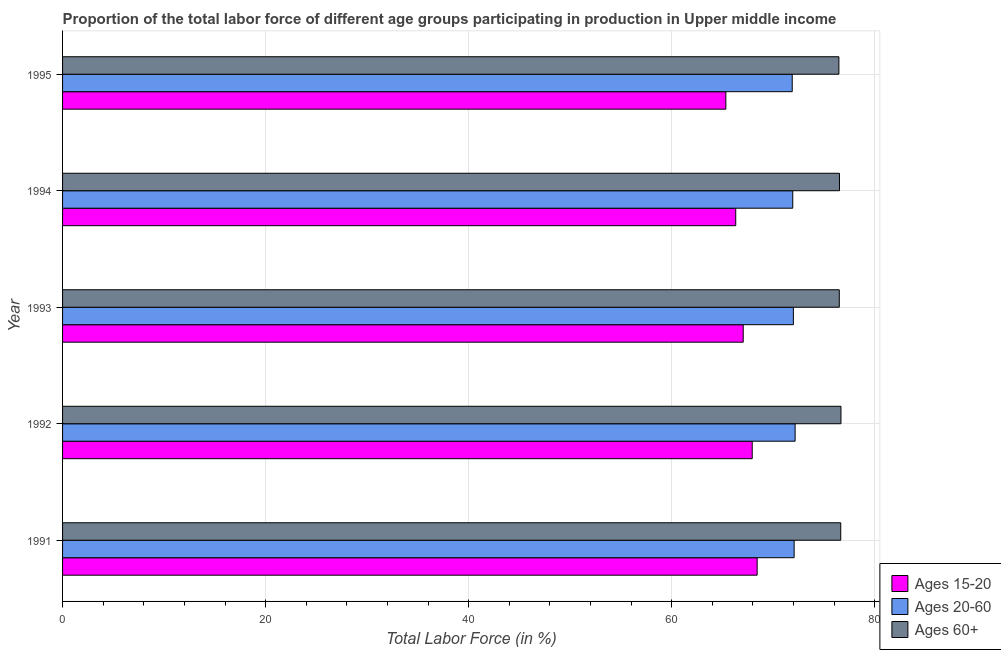How many different coloured bars are there?
Keep it short and to the point. 3. How many groups of bars are there?
Your answer should be compact. 5. Are the number of bars per tick equal to the number of legend labels?
Offer a very short reply. Yes. What is the percentage of labor force above age 60 in 1992?
Your response must be concise. 76.67. Across all years, what is the maximum percentage of labor force within the age group 20-60?
Make the answer very short. 72.16. Across all years, what is the minimum percentage of labor force above age 60?
Make the answer very short. 76.47. In which year was the percentage of labor force within the age group 15-20 maximum?
Give a very brief answer. 1991. What is the total percentage of labor force within the age group 20-60 in the graph?
Your response must be concise. 360. What is the difference between the percentage of labor force above age 60 in 1991 and that in 1994?
Your answer should be compact. 0.12. What is the difference between the percentage of labor force above age 60 in 1992 and the percentage of labor force within the age group 15-20 in 1995?
Offer a terse response. 11.34. In the year 1991, what is the difference between the percentage of labor force within the age group 20-60 and percentage of labor force above age 60?
Your answer should be very brief. -4.59. In how many years, is the percentage of labor force within the age group 20-60 greater than 28 %?
Ensure brevity in your answer.  5. What is the difference between the highest and the second highest percentage of labor force above age 60?
Offer a terse response. 0.02. What is the difference between the highest and the lowest percentage of labor force within the age group 20-60?
Your answer should be compact. 0.29. Is the sum of the percentage of labor force within the age group 20-60 in 1993 and 1995 greater than the maximum percentage of labor force within the age group 15-20 across all years?
Your answer should be very brief. Yes. What does the 2nd bar from the top in 1993 represents?
Your answer should be very brief. Ages 20-60. What does the 3rd bar from the bottom in 1992 represents?
Offer a very short reply. Ages 60+. Are all the bars in the graph horizontal?
Give a very brief answer. Yes. Are the values on the major ticks of X-axis written in scientific E-notation?
Keep it short and to the point. No. Where does the legend appear in the graph?
Provide a succinct answer. Bottom right. How are the legend labels stacked?
Provide a succinct answer. Vertical. What is the title of the graph?
Give a very brief answer. Proportion of the total labor force of different age groups participating in production in Upper middle income. What is the Total Labor Force (in %) of Ages 15-20 in 1991?
Your answer should be very brief. 68.42. What is the Total Labor Force (in %) in Ages 20-60 in 1991?
Your answer should be compact. 72.06. What is the Total Labor Force (in %) of Ages 60+ in 1991?
Keep it short and to the point. 76.65. What is the Total Labor Force (in %) of Ages 15-20 in 1992?
Provide a short and direct response. 67.93. What is the Total Labor Force (in %) of Ages 20-60 in 1992?
Offer a terse response. 72.16. What is the Total Labor Force (in %) of Ages 60+ in 1992?
Ensure brevity in your answer.  76.67. What is the Total Labor Force (in %) in Ages 15-20 in 1993?
Give a very brief answer. 67.04. What is the Total Labor Force (in %) in Ages 20-60 in 1993?
Your answer should be very brief. 71.98. What is the Total Labor Force (in %) of Ages 60+ in 1993?
Your answer should be very brief. 76.51. What is the Total Labor Force (in %) of Ages 15-20 in 1994?
Your answer should be very brief. 66.31. What is the Total Labor Force (in %) in Ages 20-60 in 1994?
Provide a short and direct response. 71.92. What is the Total Labor Force (in %) in Ages 60+ in 1994?
Provide a succinct answer. 76.53. What is the Total Labor Force (in %) of Ages 15-20 in 1995?
Provide a succinct answer. 65.33. What is the Total Labor Force (in %) in Ages 20-60 in 1995?
Provide a short and direct response. 71.87. What is the Total Labor Force (in %) in Ages 60+ in 1995?
Offer a terse response. 76.47. Across all years, what is the maximum Total Labor Force (in %) of Ages 15-20?
Give a very brief answer. 68.42. Across all years, what is the maximum Total Labor Force (in %) of Ages 20-60?
Ensure brevity in your answer.  72.16. Across all years, what is the maximum Total Labor Force (in %) of Ages 60+?
Provide a short and direct response. 76.67. Across all years, what is the minimum Total Labor Force (in %) in Ages 15-20?
Your answer should be compact. 65.33. Across all years, what is the minimum Total Labor Force (in %) in Ages 20-60?
Offer a terse response. 71.87. Across all years, what is the minimum Total Labor Force (in %) of Ages 60+?
Provide a succinct answer. 76.47. What is the total Total Labor Force (in %) of Ages 15-20 in the graph?
Give a very brief answer. 335.03. What is the total Total Labor Force (in %) of Ages 20-60 in the graph?
Offer a terse response. 360. What is the total Total Labor Force (in %) of Ages 60+ in the graph?
Ensure brevity in your answer.  382.83. What is the difference between the Total Labor Force (in %) of Ages 15-20 in 1991 and that in 1992?
Make the answer very short. 0.49. What is the difference between the Total Labor Force (in %) of Ages 20-60 in 1991 and that in 1992?
Your response must be concise. -0.1. What is the difference between the Total Labor Force (in %) in Ages 60+ in 1991 and that in 1992?
Provide a short and direct response. -0.02. What is the difference between the Total Labor Force (in %) of Ages 15-20 in 1991 and that in 1993?
Your answer should be compact. 1.37. What is the difference between the Total Labor Force (in %) in Ages 20-60 in 1991 and that in 1993?
Your response must be concise. 0.08. What is the difference between the Total Labor Force (in %) of Ages 60+ in 1991 and that in 1993?
Provide a succinct answer. 0.14. What is the difference between the Total Labor Force (in %) in Ages 15-20 in 1991 and that in 1994?
Make the answer very short. 2.11. What is the difference between the Total Labor Force (in %) in Ages 20-60 in 1991 and that in 1994?
Make the answer very short. 0.14. What is the difference between the Total Labor Force (in %) in Ages 60+ in 1991 and that in 1994?
Your answer should be compact. 0.12. What is the difference between the Total Labor Force (in %) in Ages 15-20 in 1991 and that in 1995?
Provide a succinct answer. 3.09. What is the difference between the Total Labor Force (in %) in Ages 20-60 in 1991 and that in 1995?
Offer a very short reply. 0.19. What is the difference between the Total Labor Force (in %) of Ages 60+ in 1991 and that in 1995?
Make the answer very short. 0.18. What is the difference between the Total Labor Force (in %) of Ages 15-20 in 1992 and that in 1993?
Offer a very short reply. 0.89. What is the difference between the Total Labor Force (in %) of Ages 20-60 in 1992 and that in 1993?
Make the answer very short. 0.17. What is the difference between the Total Labor Force (in %) in Ages 60+ in 1992 and that in 1993?
Your answer should be compact. 0.16. What is the difference between the Total Labor Force (in %) in Ages 15-20 in 1992 and that in 1994?
Provide a succinct answer. 1.62. What is the difference between the Total Labor Force (in %) of Ages 20-60 in 1992 and that in 1994?
Ensure brevity in your answer.  0.23. What is the difference between the Total Labor Force (in %) of Ages 60+ in 1992 and that in 1994?
Make the answer very short. 0.15. What is the difference between the Total Labor Force (in %) of Ages 15-20 in 1992 and that in 1995?
Give a very brief answer. 2.6. What is the difference between the Total Labor Force (in %) of Ages 20-60 in 1992 and that in 1995?
Make the answer very short. 0.29. What is the difference between the Total Labor Force (in %) in Ages 60+ in 1992 and that in 1995?
Make the answer very short. 0.2. What is the difference between the Total Labor Force (in %) in Ages 15-20 in 1993 and that in 1994?
Your response must be concise. 0.74. What is the difference between the Total Labor Force (in %) in Ages 20-60 in 1993 and that in 1994?
Make the answer very short. 0.06. What is the difference between the Total Labor Force (in %) of Ages 60+ in 1993 and that in 1994?
Ensure brevity in your answer.  -0.02. What is the difference between the Total Labor Force (in %) of Ages 15-20 in 1993 and that in 1995?
Your response must be concise. 1.71. What is the difference between the Total Labor Force (in %) in Ages 20-60 in 1993 and that in 1995?
Your answer should be very brief. 0.11. What is the difference between the Total Labor Force (in %) of Ages 60+ in 1993 and that in 1995?
Keep it short and to the point. 0.04. What is the difference between the Total Labor Force (in %) in Ages 15-20 in 1994 and that in 1995?
Make the answer very short. 0.98. What is the difference between the Total Labor Force (in %) in Ages 20-60 in 1994 and that in 1995?
Your answer should be compact. 0.05. What is the difference between the Total Labor Force (in %) in Ages 60+ in 1994 and that in 1995?
Make the answer very short. 0.06. What is the difference between the Total Labor Force (in %) in Ages 15-20 in 1991 and the Total Labor Force (in %) in Ages 20-60 in 1992?
Keep it short and to the point. -3.74. What is the difference between the Total Labor Force (in %) of Ages 15-20 in 1991 and the Total Labor Force (in %) of Ages 60+ in 1992?
Your response must be concise. -8.25. What is the difference between the Total Labor Force (in %) of Ages 20-60 in 1991 and the Total Labor Force (in %) of Ages 60+ in 1992?
Give a very brief answer. -4.61. What is the difference between the Total Labor Force (in %) in Ages 15-20 in 1991 and the Total Labor Force (in %) in Ages 20-60 in 1993?
Provide a succinct answer. -3.57. What is the difference between the Total Labor Force (in %) in Ages 15-20 in 1991 and the Total Labor Force (in %) in Ages 60+ in 1993?
Your response must be concise. -8.09. What is the difference between the Total Labor Force (in %) in Ages 20-60 in 1991 and the Total Labor Force (in %) in Ages 60+ in 1993?
Provide a short and direct response. -4.45. What is the difference between the Total Labor Force (in %) of Ages 15-20 in 1991 and the Total Labor Force (in %) of Ages 20-60 in 1994?
Your response must be concise. -3.51. What is the difference between the Total Labor Force (in %) in Ages 15-20 in 1991 and the Total Labor Force (in %) in Ages 60+ in 1994?
Give a very brief answer. -8.11. What is the difference between the Total Labor Force (in %) in Ages 20-60 in 1991 and the Total Labor Force (in %) in Ages 60+ in 1994?
Offer a terse response. -4.47. What is the difference between the Total Labor Force (in %) of Ages 15-20 in 1991 and the Total Labor Force (in %) of Ages 20-60 in 1995?
Keep it short and to the point. -3.45. What is the difference between the Total Labor Force (in %) of Ages 15-20 in 1991 and the Total Labor Force (in %) of Ages 60+ in 1995?
Make the answer very short. -8.05. What is the difference between the Total Labor Force (in %) in Ages 20-60 in 1991 and the Total Labor Force (in %) in Ages 60+ in 1995?
Give a very brief answer. -4.41. What is the difference between the Total Labor Force (in %) in Ages 15-20 in 1992 and the Total Labor Force (in %) in Ages 20-60 in 1993?
Your answer should be compact. -4.05. What is the difference between the Total Labor Force (in %) of Ages 15-20 in 1992 and the Total Labor Force (in %) of Ages 60+ in 1993?
Provide a succinct answer. -8.58. What is the difference between the Total Labor Force (in %) in Ages 20-60 in 1992 and the Total Labor Force (in %) in Ages 60+ in 1993?
Provide a short and direct response. -4.35. What is the difference between the Total Labor Force (in %) in Ages 15-20 in 1992 and the Total Labor Force (in %) in Ages 20-60 in 1994?
Provide a succinct answer. -3.99. What is the difference between the Total Labor Force (in %) in Ages 15-20 in 1992 and the Total Labor Force (in %) in Ages 60+ in 1994?
Provide a succinct answer. -8.6. What is the difference between the Total Labor Force (in %) in Ages 20-60 in 1992 and the Total Labor Force (in %) in Ages 60+ in 1994?
Your response must be concise. -4.37. What is the difference between the Total Labor Force (in %) of Ages 15-20 in 1992 and the Total Labor Force (in %) of Ages 20-60 in 1995?
Make the answer very short. -3.94. What is the difference between the Total Labor Force (in %) in Ages 15-20 in 1992 and the Total Labor Force (in %) in Ages 60+ in 1995?
Offer a terse response. -8.54. What is the difference between the Total Labor Force (in %) in Ages 20-60 in 1992 and the Total Labor Force (in %) in Ages 60+ in 1995?
Keep it short and to the point. -4.31. What is the difference between the Total Labor Force (in %) in Ages 15-20 in 1993 and the Total Labor Force (in %) in Ages 20-60 in 1994?
Provide a succinct answer. -4.88. What is the difference between the Total Labor Force (in %) in Ages 15-20 in 1993 and the Total Labor Force (in %) in Ages 60+ in 1994?
Your answer should be compact. -9.48. What is the difference between the Total Labor Force (in %) in Ages 20-60 in 1993 and the Total Labor Force (in %) in Ages 60+ in 1994?
Your answer should be very brief. -4.54. What is the difference between the Total Labor Force (in %) of Ages 15-20 in 1993 and the Total Labor Force (in %) of Ages 20-60 in 1995?
Provide a short and direct response. -4.83. What is the difference between the Total Labor Force (in %) of Ages 15-20 in 1993 and the Total Labor Force (in %) of Ages 60+ in 1995?
Ensure brevity in your answer.  -9.42. What is the difference between the Total Labor Force (in %) in Ages 20-60 in 1993 and the Total Labor Force (in %) in Ages 60+ in 1995?
Provide a short and direct response. -4.48. What is the difference between the Total Labor Force (in %) in Ages 15-20 in 1994 and the Total Labor Force (in %) in Ages 20-60 in 1995?
Ensure brevity in your answer.  -5.56. What is the difference between the Total Labor Force (in %) of Ages 15-20 in 1994 and the Total Labor Force (in %) of Ages 60+ in 1995?
Your answer should be very brief. -10.16. What is the difference between the Total Labor Force (in %) of Ages 20-60 in 1994 and the Total Labor Force (in %) of Ages 60+ in 1995?
Provide a succinct answer. -4.54. What is the average Total Labor Force (in %) of Ages 15-20 per year?
Offer a terse response. 67.01. What is the average Total Labor Force (in %) in Ages 20-60 per year?
Your answer should be compact. 72. What is the average Total Labor Force (in %) of Ages 60+ per year?
Provide a short and direct response. 76.57. In the year 1991, what is the difference between the Total Labor Force (in %) of Ages 15-20 and Total Labor Force (in %) of Ages 20-60?
Provide a succinct answer. -3.64. In the year 1991, what is the difference between the Total Labor Force (in %) of Ages 15-20 and Total Labor Force (in %) of Ages 60+?
Your answer should be compact. -8.23. In the year 1991, what is the difference between the Total Labor Force (in %) in Ages 20-60 and Total Labor Force (in %) in Ages 60+?
Give a very brief answer. -4.59. In the year 1992, what is the difference between the Total Labor Force (in %) of Ages 15-20 and Total Labor Force (in %) of Ages 20-60?
Ensure brevity in your answer.  -4.23. In the year 1992, what is the difference between the Total Labor Force (in %) of Ages 15-20 and Total Labor Force (in %) of Ages 60+?
Provide a short and direct response. -8.74. In the year 1992, what is the difference between the Total Labor Force (in %) of Ages 20-60 and Total Labor Force (in %) of Ages 60+?
Provide a short and direct response. -4.52. In the year 1993, what is the difference between the Total Labor Force (in %) in Ages 15-20 and Total Labor Force (in %) in Ages 20-60?
Provide a short and direct response. -4.94. In the year 1993, what is the difference between the Total Labor Force (in %) in Ages 15-20 and Total Labor Force (in %) in Ages 60+?
Offer a very short reply. -9.46. In the year 1993, what is the difference between the Total Labor Force (in %) of Ages 20-60 and Total Labor Force (in %) of Ages 60+?
Keep it short and to the point. -4.52. In the year 1994, what is the difference between the Total Labor Force (in %) of Ages 15-20 and Total Labor Force (in %) of Ages 20-60?
Offer a very short reply. -5.62. In the year 1994, what is the difference between the Total Labor Force (in %) of Ages 15-20 and Total Labor Force (in %) of Ages 60+?
Make the answer very short. -10.22. In the year 1994, what is the difference between the Total Labor Force (in %) in Ages 20-60 and Total Labor Force (in %) in Ages 60+?
Make the answer very short. -4.6. In the year 1995, what is the difference between the Total Labor Force (in %) of Ages 15-20 and Total Labor Force (in %) of Ages 20-60?
Keep it short and to the point. -6.54. In the year 1995, what is the difference between the Total Labor Force (in %) in Ages 15-20 and Total Labor Force (in %) in Ages 60+?
Make the answer very short. -11.14. In the year 1995, what is the difference between the Total Labor Force (in %) in Ages 20-60 and Total Labor Force (in %) in Ages 60+?
Your response must be concise. -4.6. What is the ratio of the Total Labor Force (in %) in Ages 20-60 in 1991 to that in 1992?
Your answer should be compact. 1. What is the ratio of the Total Labor Force (in %) of Ages 15-20 in 1991 to that in 1993?
Provide a succinct answer. 1.02. What is the ratio of the Total Labor Force (in %) of Ages 60+ in 1991 to that in 1993?
Offer a terse response. 1. What is the ratio of the Total Labor Force (in %) in Ages 15-20 in 1991 to that in 1994?
Offer a very short reply. 1.03. What is the ratio of the Total Labor Force (in %) of Ages 15-20 in 1991 to that in 1995?
Offer a very short reply. 1.05. What is the ratio of the Total Labor Force (in %) in Ages 60+ in 1991 to that in 1995?
Your answer should be compact. 1. What is the ratio of the Total Labor Force (in %) in Ages 15-20 in 1992 to that in 1993?
Your response must be concise. 1.01. What is the ratio of the Total Labor Force (in %) of Ages 15-20 in 1992 to that in 1994?
Provide a succinct answer. 1.02. What is the ratio of the Total Labor Force (in %) in Ages 20-60 in 1992 to that in 1994?
Your answer should be very brief. 1. What is the ratio of the Total Labor Force (in %) in Ages 15-20 in 1992 to that in 1995?
Give a very brief answer. 1.04. What is the ratio of the Total Labor Force (in %) of Ages 20-60 in 1992 to that in 1995?
Your answer should be compact. 1. What is the ratio of the Total Labor Force (in %) of Ages 15-20 in 1993 to that in 1994?
Make the answer very short. 1.01. What is the ratio of the Total Labor Force (in %) in Ages 20-60 in 1993 to that in 1994?
Ensure brevity in your answer.  1. What is the ratio of the Total Labor Force (in %) of Ages 15-20 in 1993 to that in 1995?
Your response must be concise. 1.03. What is the ratio of the Total Labor Force (in %) of Ages 20-60 in 1993 to that in 1995?
Keep it short and to the point. 1. What is the ratio of the Total Labor Force (in %) of Ages 15-20 in 1994 to that in 1995?
Give a very brief answer. 1.01. What is the ratio of the Total Labor Force (in %) in Ages 60+ in 1994 to that in 1995?
Your answer should be very brief. 1. What is the difference between the highest and the second highest Total Labor Force (in %) of Ages 15-20?
Provide a succinct answer. 0.49. What is the difference between the highest and the second highest Total Labor Force (in %) of Ages 20-60?
Give a very brief answer. 0.1. What is the difference between the highest and the second highest Total Labor Force (in %) of Ages 60+?
Make the answer very short. 0.02. What is the difference between the highest and the lowest Total Labor Force (in %) of Ages 15-20?
Keep it short and to the point. 3.09. What is the difference between the highest and the lowest Total Labor Force (in %) of Ages 20-60?
Make the answer very short. 0.29. What is the difference between the highest and the lowest Total Labor Force (in %) of Ages 60+?
Offer a terse response. 0.2. 